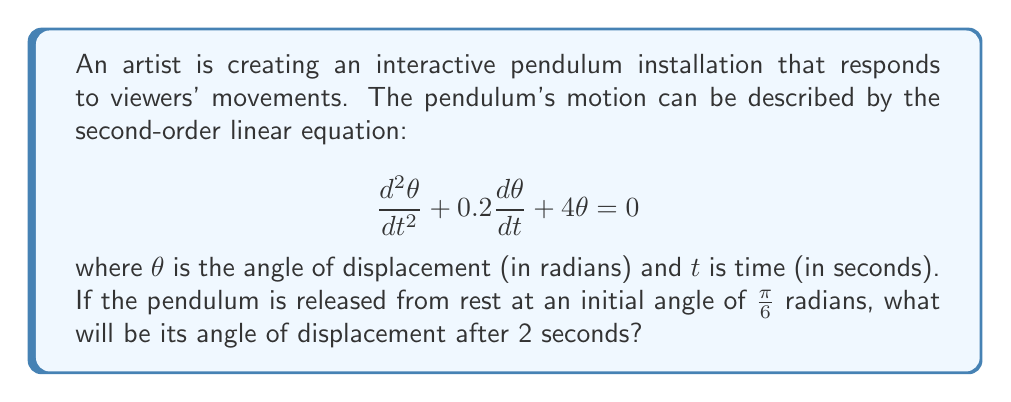Solve this math problem. To solve this problem, we need to follow these steps:

1) The general solution for this second-order linear equation is:

   $$\theta(t) = e^{-0.1t}(A\cos(1.99t) + B\sin(1.99t))$$

   Where $A$ and $B$ are constants determined by initial conditions.

2) We're given two initial conditions:
   - At $t=0$, $\theta(0) = \frac{\pi}{6}$
   - At $t=0$, $\frac{d\theta}{dt}(0) = 0$ (released from rest)

3) Using the first condition:

   $$\frac{\pi}{6} = A\cos(0) + B\sin(0) = A$$

4) For the second condition, we differentiate $\theta(t)$:

   $$\frac{d\theta}{dt} = -0.1e^{-0.1t}(A\cos(1.99t) + B\sin(1.99t)) + e^{-0.1t}(-1.99A\sin(1.99t) + 1.99B\cos(1.99t))$$

   At $t=0$, this should equal 0:

   $$0 = -0.1A + 1.99B$$

5) Solving these equations:

   $$A = \frac{\pi}{6}$$
   $$B = \frac{0.1A}{1.99} = \frac{0.1\pi}{11.94}$$

6) Now we can write our specific solution:

   $$\theta(t) = e^{-0.1t}(\frac{\pi}{6}\cos(1.99t) + \frac{0.1\pi}{11.94}\sin(1.99t))$$

7) To find $\theta(2)$, we plug in $t=2$:

   $$\theta(2) = e^{-0.2}(\frac{\pi}{6}\cos(3.98) + \frac{0.1\pi}{11.94}\sin(3.98))$$

8) Calculating this (you may use a calculator):

   $$\theta(2) \approx 0.2618 \text{ radians}$$
Answer: The angle of displacement after 2 seconds will be approximately 0.2618 radians. 